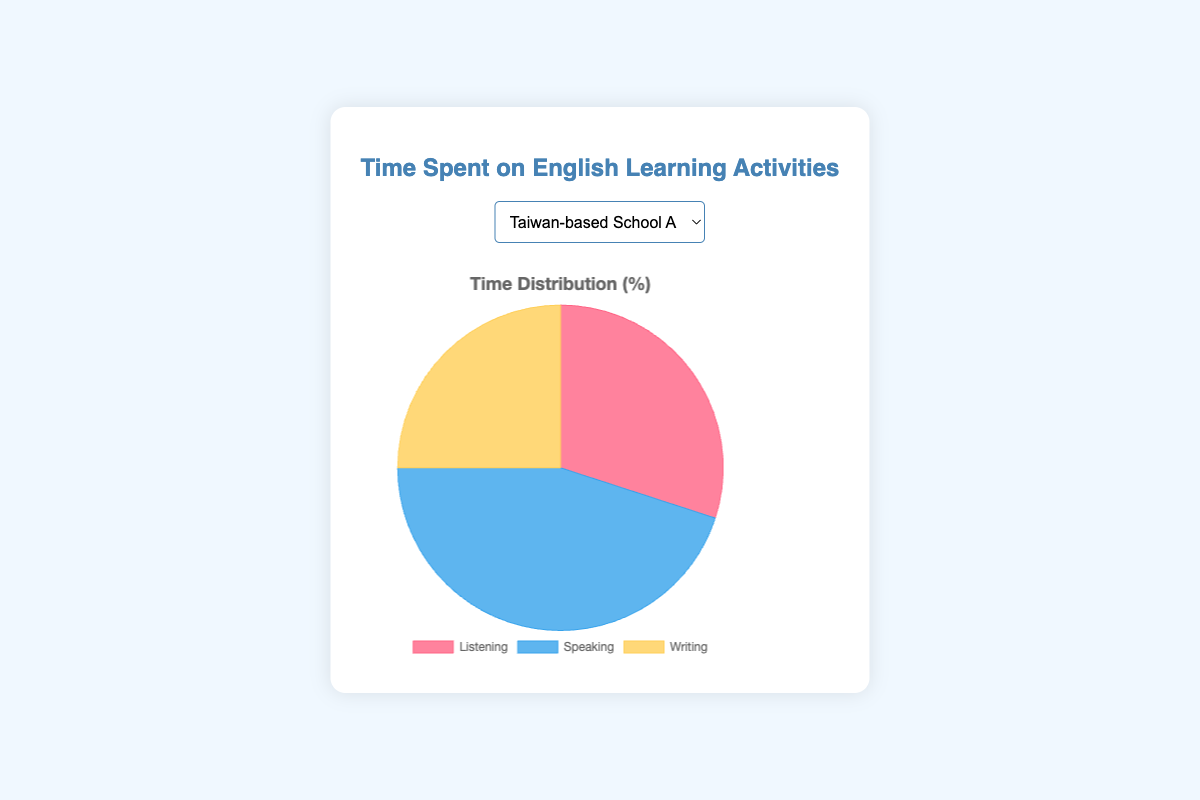Which activity has the highest time allocation in Taiwan-based School A? The largest slice in the pie chart for Taiwan-based School A represents Speaking, which occupies the biggest portion of the chart.
Answer: Speaking What is the combined time spent on Listening and Writing in Taiwan-based School B? According to the pie chart for Taiwan-based School B, the time spent on Listening is 35%, and on Writing is 25%. Combined, this amounts to 35 + 25 = 60%.
Answer: 60% In Taiwan-based School D, how much more time is spent on Speaking than Listening? The pie chart shows 50% spent on Speaking and 20% on Listening in Taiwan-based School D. The difference is 50 - 20 = 30%.
Answer: 30% Which school spends the least amount of time on Listening? By comparing the pie slices representing Listening across all schools, Taiwan-based School D has the smallest slice for Listening at 20%.
Answer: Taiwan-based School D If we average the time spent on Speaking across all schools, what would be the result? To find the average time spent on Speaking, sum the percentage values: 45 + 40 + 50 + 50 + 35 + 40 = 260%. There are 6 schools, so the average is 260 / 6 ≈ 43.33%.
Answer: 43.33% What is the total time spent on Speaking and Writing in Taiwan-based School C? For Taiwan-based School C, the pie chart shows 50% for Speaking and 25% for Writing, making a total of 50 + 25 = 75%.
Answer: 75% In Taiwan-based School E, which activity occupies the largest proportion of the pie chart? The pie chart for Taiwan-based School E shows the largest portion dedicated to Listening at 40%.
Answer: Listening Which school spends equally on Writing and Listening? A review of the pie charts reveals that Taiwan-based Schools B and C both spend 25% on Writing and Listening.
Answer: Taiwan-based School B and Taiwan-based School C How much more time does Taiwan-based School F spend on writing than Taiwan-based School A? Taiwan-based School F spends 30% on Writing, while Taiwan-based School A spends 25%. The difference is 30 - 25 = 5%.
Answer: 5% In Taiwan-based School D, what is the ratio of time spent on Speaking to Writing? Taiwan-based School D's pie chart shows 50% for Speaking and 30% for Writing, so the ratio is 50 to 30, which simplifies to 5:3.
Answer: 5:3 